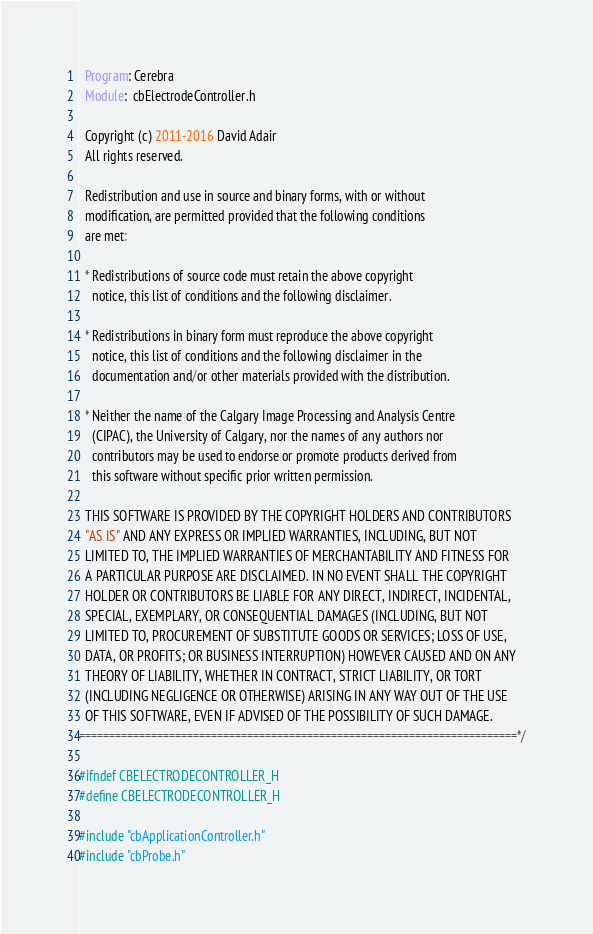Convert code to text. <code><loc_0><loc_0><loc_500><loc_500><_C_>  Program: Cerebra
  Module:  cbElectrodeController.h

  Copyright (c) 2011-2016 David Adair
  All rights reserved.

  Redistribution and use in source and binary forms, with or without
  modification, are permitted provided that the following conditions
  are met:

  * Redistributions of source code must retain the above copyright
    notice, this list of conditions and the following disclaimer.

  * Redistributions in binary form must reproduce the above copyright
    notice, this list of conditions and the following disclaimer in the
    documentation and/or other materials provided with the distribution.

  * Neither the name of the Calgary Image Processing and Analysis Centre
    (CIPAC), the University of Calgary, nor the names of any authors nor
    contributors may be used to endorse or promote products derived from
    this software without specific prior written permission.

  THIS SOFTWARE IS PROVIDED BY THE COPYRIGHT HOLDERS AND CONTRIBUTORS
  "AS IS" AND ANY EXPRESS OR IMPLIED WARRANTIES, INCLUDING, BUT NOT
  LIMITED TO, THE IMPLIED WARRANTIES OF MERCHANTABILITY AND FITNESS FOR
  A PARTICULAR PURPOSE ARE DISCLAIMED. IN NO EVENT SHALL THE COPYRIGHT
  HOLDER OR CONTRIBUTORS BE LIABLE FOR ANY DIRECT, INDIRECT, INCIDENTAL,
  SPECIAL, EXEMPLARY, OR CONSEQUENTIAL DAMAGES (INCLUDING, BUT NOT
  LIMITED TO, PROCUREMENT OF SUBSTITUTE GOODS OR SERVICES; LOSS OF USE,
  DATA, OR PROFITS; OR BUSINESS INTERRUPTION) HOWEVER CAUSED AND ON ANY
  THEORY OF LIABILITY, WHETHER IN CONTRACT, STRICT LIABILITY, OR TORT
  (INCLUDING NEGLIGENCE OR OTHERWISE) ARISING IN ANY WAY OUT OF THE USE
  OF THIS SOFTWARE, EVEN IF ADVISED OF THE POSSIBILITY OF SUCH DAMAGE.
=========================================================================*/

#ifndef CBELECTRODECONTROLLER_H
#define CBELECTRODECONTROLLER_H

#include "cbApplicationController.h"
#include "cbProbe.h"</code> 